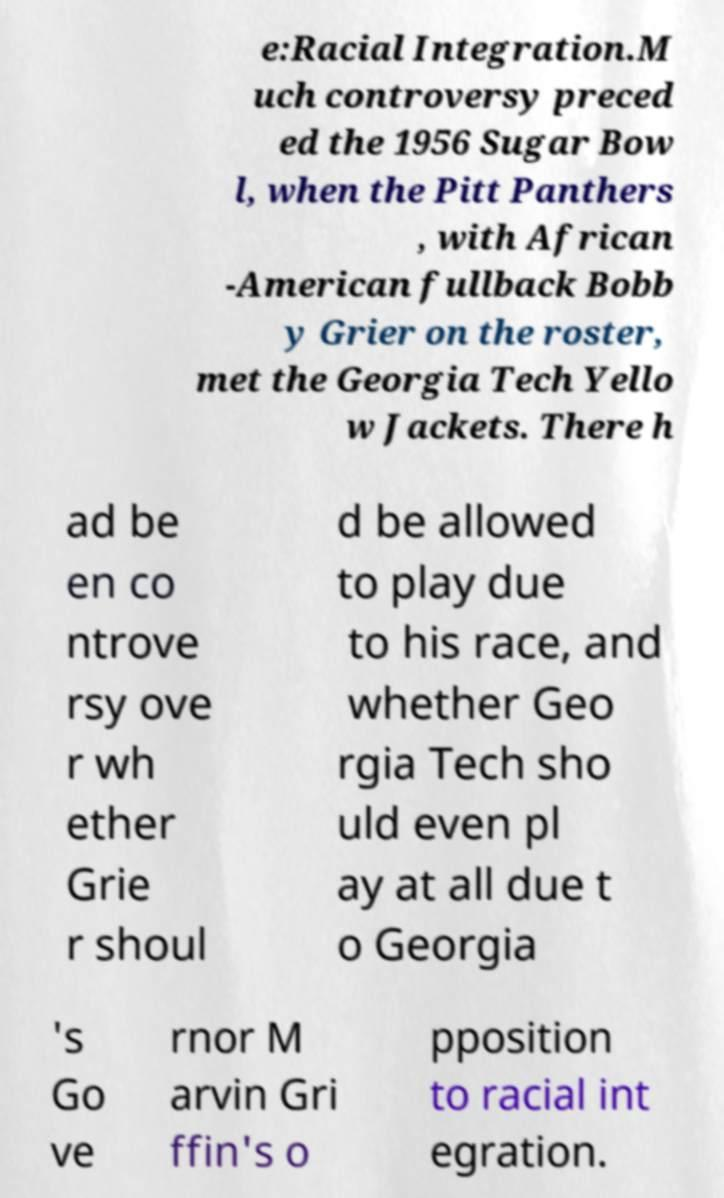Please identify and transcribe the text found in this image. e:Racial Integration.M uch controversy preced ed the 1956 Sugar Bow l, when the Pitt Panthers , with African -American fullback Bobb y Grier on the roster, met the Georgia Tech Yello w Jackets. There h ad be en co ntrove rsy ove r wh ether Grie r shoul d be allowed to play due to his race, and whether Geo rgia Tech sho uld even pl ay at all due t o Georgia 's Go ve rnor M arvin Gri ffin's o pposition to racial int egration. 